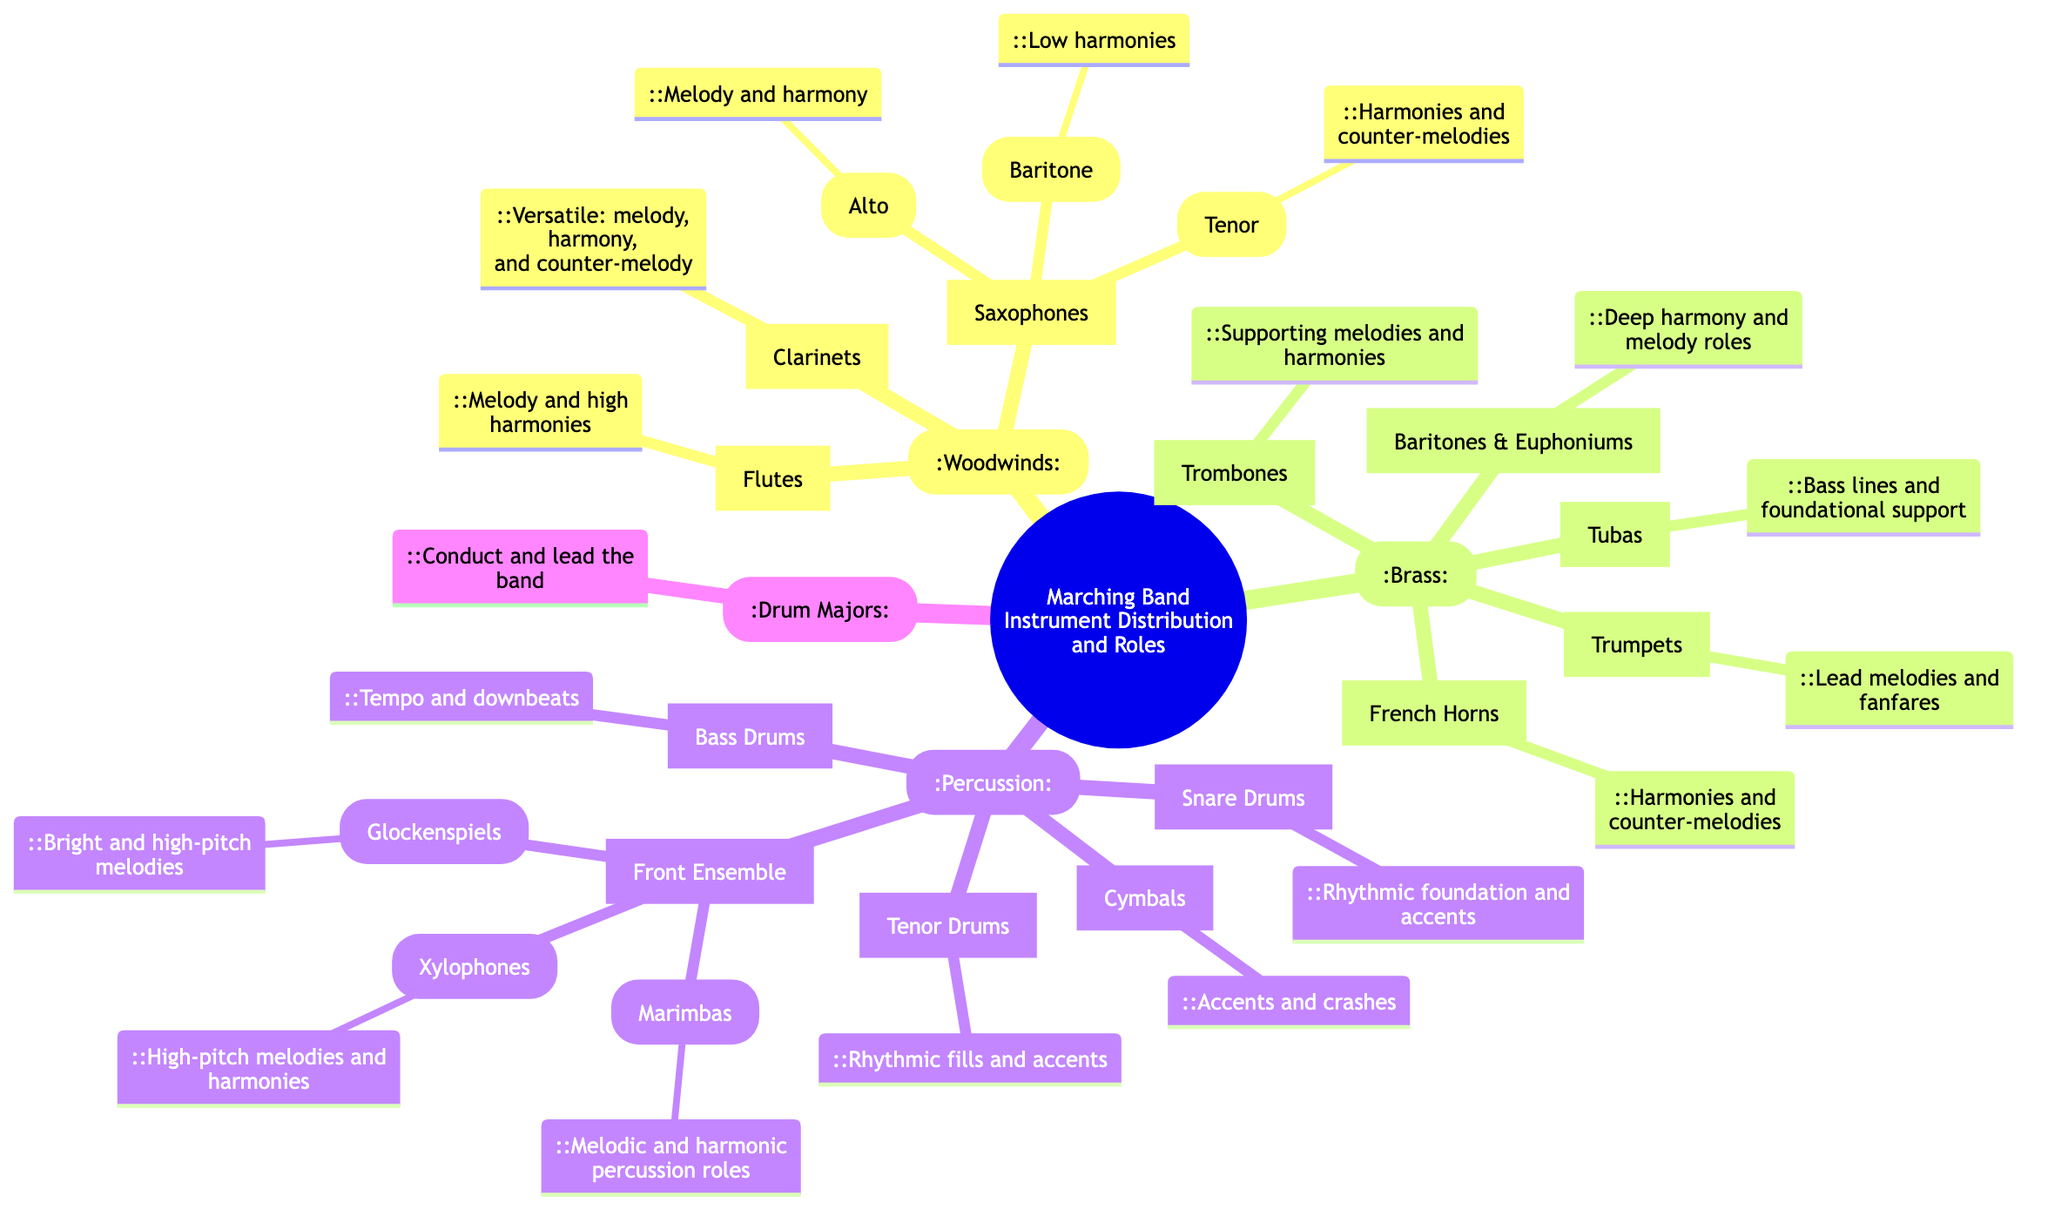What are the main sections of the marching band? The diagram shows four main sections: Woodwinds, Brass, Percussion, and Drum Majors. Each section is distinctly labeled in the root of the diagram.
Answer: Woodwinds, Brass, Percussion, Drum Majors How many woodwind instruments are listed? The woodwind section includes three types of instruments: Flutes, Clarinets, and Saxophones (which has three sub-types). Counting all together, there are seven distinct items in the woodwinds section.
Answer: 7 Which brass instrument leads melodies and fanfares? The Trumpets are specified as the instruments that lead melodies and fanfares according to the description next to it in the diagram.
Answer: Trumpets What role do Trombones play in the marching band? The diagram states that Trombones support melodies and harmonies, detailing their specific function within the brass section of the band.
Answer: Supporting melodies and harmonies Which percussion instrument provides the rhythmic foundation? Snare Drums are highlighted for their role as the rhythmic foundation and accents, making them key to the percussion section's function.
Answer: Snare Drums How many types of saxophones are mentioned? The diagram lists three types of saxophones: Alto, Tenor, and Baritone. Each is categorized under the woodwinds section, directly reflecting their specialty roles.
Answer: 3 What is the primary function of the Bass Drums? The Bass Drums are described in the diagram as responsible for keeping the tempo and downbeats, which clarifies their essential role in maintaining the overall rhythm.
Answer: Tempo and downbeats What do Drum Majors do? The diagram clearly states that Drum Majors conduct and lead the band, showcasing their leadership role within the marching band structure.
Answer: Conduct and lead the band Which front ensemble instrument plays high-pitch melodies and harmonies? The Xylophones are identified in the diagram as playing high-pitch melodies and harmonies, highlighting their uniqueness within the front ensemble category.
Answer: Xylophones 